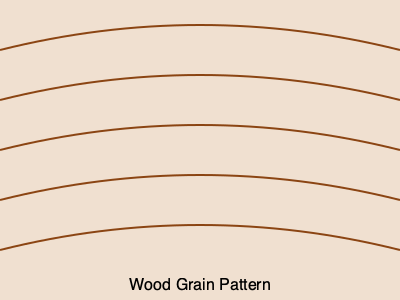In vintage furniture restoration, which wood grain pattern is depicted in the image above, characterized by its wavy, flowing lines that resemble ripples on water? To identify the wood grain pattern shown in the image, let's break down the characteristics:

1. The pattern consists of curved, wavy lines.
2. These lines flow across the surface in a parallel manner.
3. The curves create a ripple-like effect, reminiscent of water's surface.
4. The pattern is continuous and repeating.

These characteristics are typical of a specific wood grain pattern known as "curly" or "fiddleback." This pattern is most commonly found in maple, but can also occur in other species like cherry, birch, or ash.

The curly grain is caused by irregularities in wood growth, where the tree fibers grow in a wavy pattern instead of straight. This results in the distinctive ripple-like appearance when the wood is cut and finished.

In vintage furniture restoration, recognizing this pattern is crucial because:

1. It's highly prized for its aesthetic value.
2. Pieces with curly grain often require special care during refinishing to preserve and enhance the pattern.
3. Understanding the grain helps in choosing appropriate finishing techniques to highlight its beauty.

Therefore, based on the wavy, ripple-like pattern shown in the image, the wood grain pattern depicted is curly or fiddleback.
Answer: Curly (or fiddleback) grain 